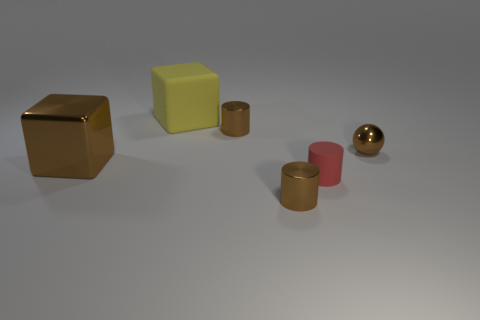What time of day or lighting scenario does the image seem to represent? The image seems to be set in an environment with soft, diffused lighting, likely an indoor scene with an overhead light source. There are no harsh shadows or bright highlights, which indicates that the lighting isn't very intense. This could represent a scenario with artificial lighting, typical for interior spaces. 